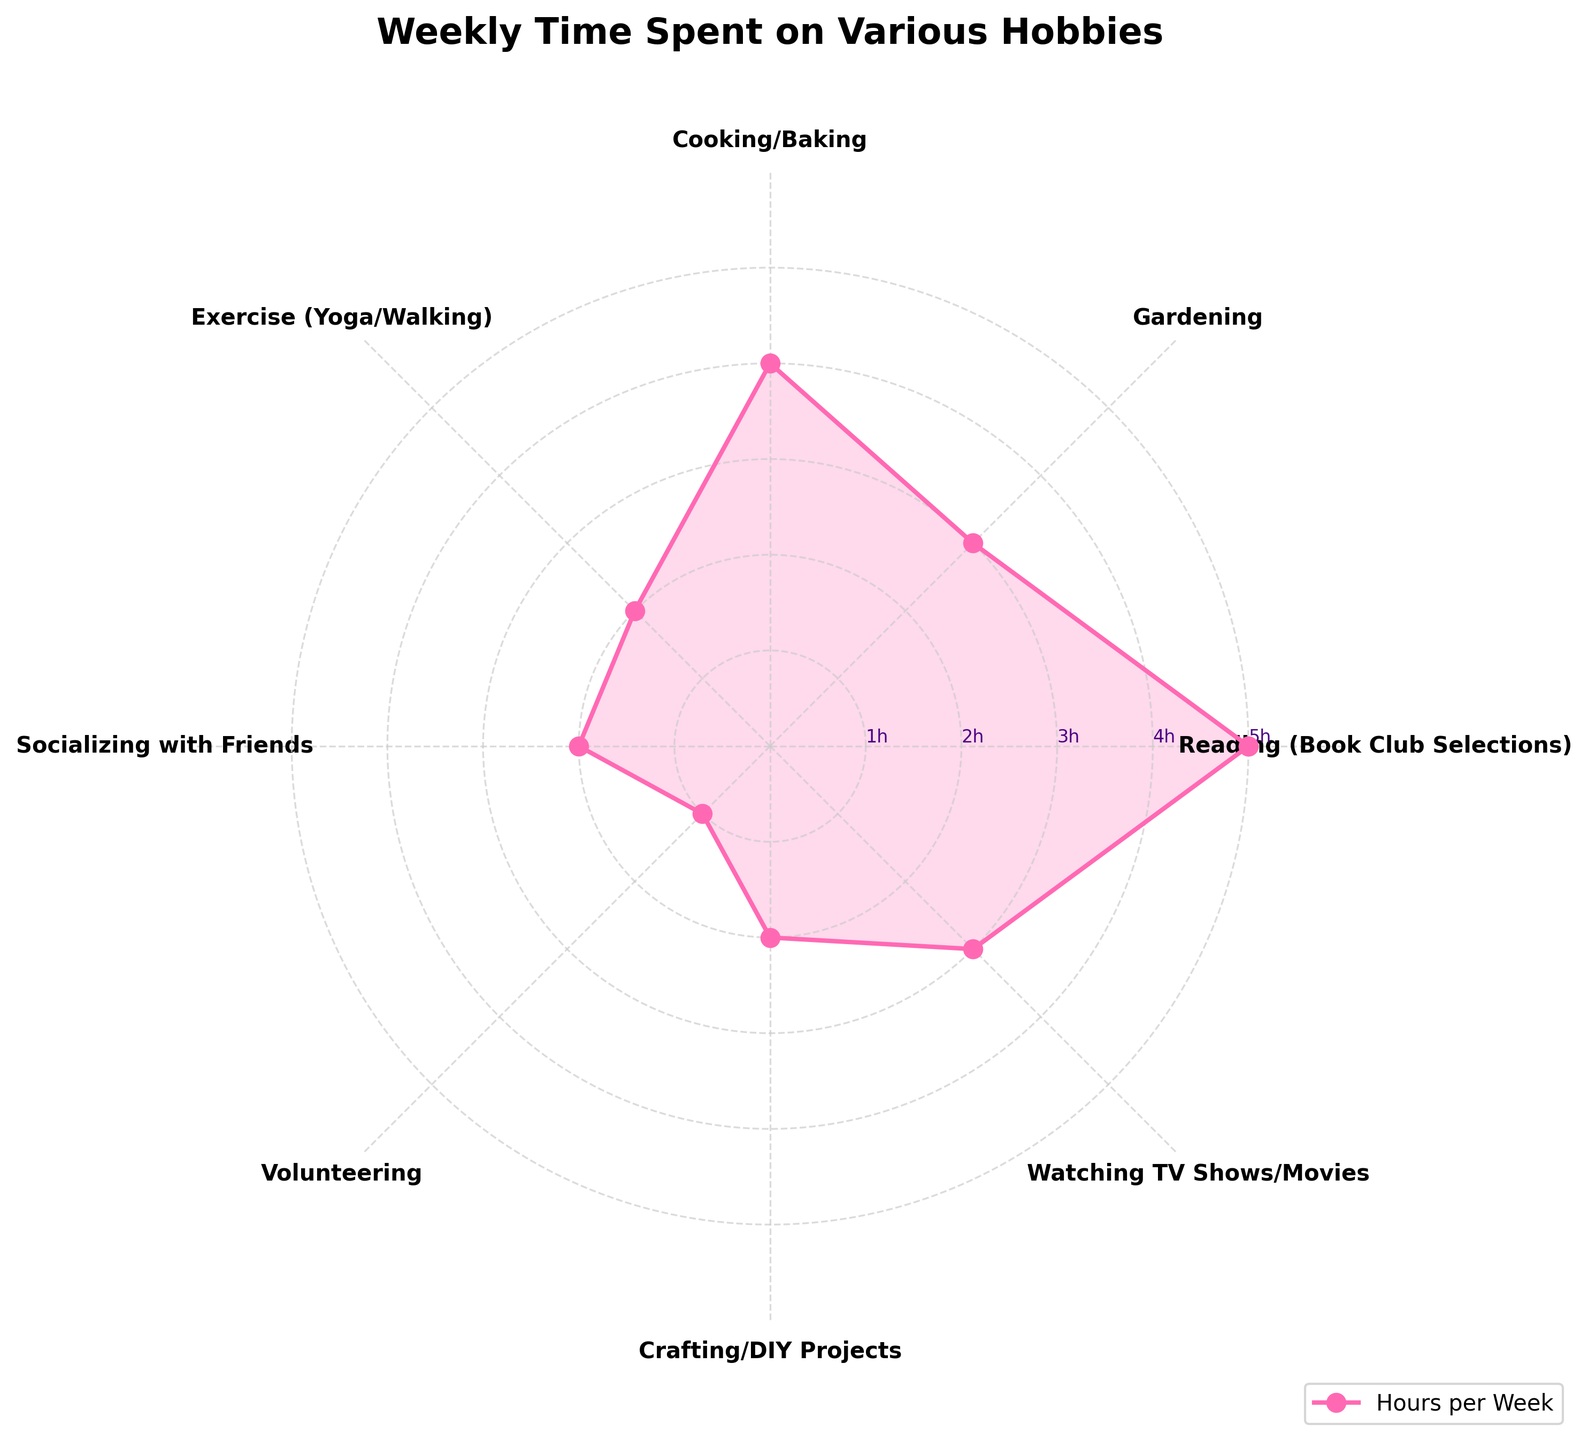What's the title of the Polar Chart? The title of the Polar Chart is displayed at the top of the figure, indicating what the chart represents.
Answer: Weekly Time Spent on Various Hobbies How many hours per week are spent on Cooking/Baking? Locate the section labeled "Cooking/Baking" on the chart and note the corresponding radial value which shows the hours.
Answer: 4 Which hobby has the highest number of hours per week? Identify the peak radial value on the chart and the corresponding hobby label.
Answer: Reading (Book Club Selections) How many hobbies have 2 hours or less spent per week? Count the hobby labels on the chart that fall within or on the 2-hour radial circle.
Answer: 4 How does the time spent on Gardening compare to Watching TV Shows/Movies? Compare the radial values for both "Gardening" and "Watching TV Shows/Movies".
Answer: Equal (3 hours each) What is the total number of hours spent on hobbies marked as 2 hours a week? Sum the hours for hobbies labeled with 2 hours per week: Exercise (Yoga/Walking), Socializing with Friends, and Crafting/DIY Projects.
Answer: 6 What's the average number of hours spent per week across all hobbies? Sum the hours for all hobbies and divide by the total number of hobbies. (5+3+4+2+2+1+2+3)/8 = 22/8.
Answer: 2.75 Which hobbies have an equal amount of time spent on them? Identify the hobbies with matching radial values on the chart.
Answer: Gardening and Watching TV Shows/Movies; Exercise (Yoga/Walking), Socializing with Friends, and Crafting/DIY Projects What's the difference in hours between the hobby with the most time spent and the hobby with the least time spent? Find the difference between the highest radial value and the lowest radial value, which corresponds to the hours spent on Reading (Book Club Selections) and Volunteering.
Answer: 4 If I spent 1 extra hour per week on Exercise (Yoga/Walking), would it still have the same amount of time as any other hobby? Add 1 hour to the Exercise (Yoga/Walking) value and compare it to the other values on the chart. Initially, it was 2, so adding 1 hour results in 3, matching Gardening and Watching TV Shows/Movies.
Answer: Yes 